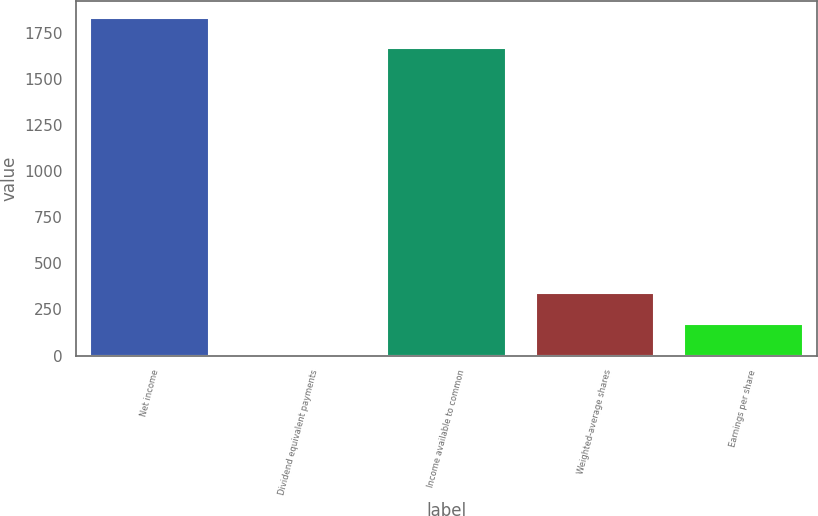Convert chart. <chart><loc_0><loc_0><loc_500><loc_500><bar_chart><fcel>Net income<fcel>Dividend equivalent payments<fcel>Income available to common<fcel>Weighted-average shares<fcel>Earnings per share<nl><fcel>1830.4<fcel>4<fcel>1664<fcel>336.8<fcel>170.4<nl></chart> 